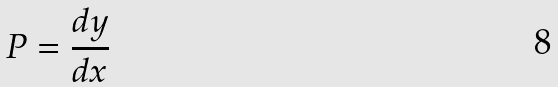Convert formula to latex. <formula><loc_0><loc_0><loc_500><loc_500>P = \frac { d y } { d x }</formula> 